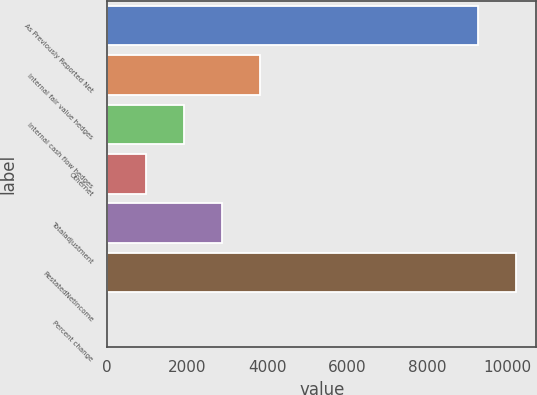Convert chart to OTSL. <chart><loc_0><loc_0><loc_500><loc_500><bar_chart><fcel>As Previously Reported Net<fcel>Internal fair value hedges<fcel>Internal cash flow hedges<fcel>Othernet<fcel>Totaladjustment<fcel>RestatedNetincome<fcel>Percent change<nl><fcel>9249<fcel>3823.18<fcel>1913.24<fcel>958.27<fcel>2868.21<fcel>10204<fcel>3.3<nl></chart> 